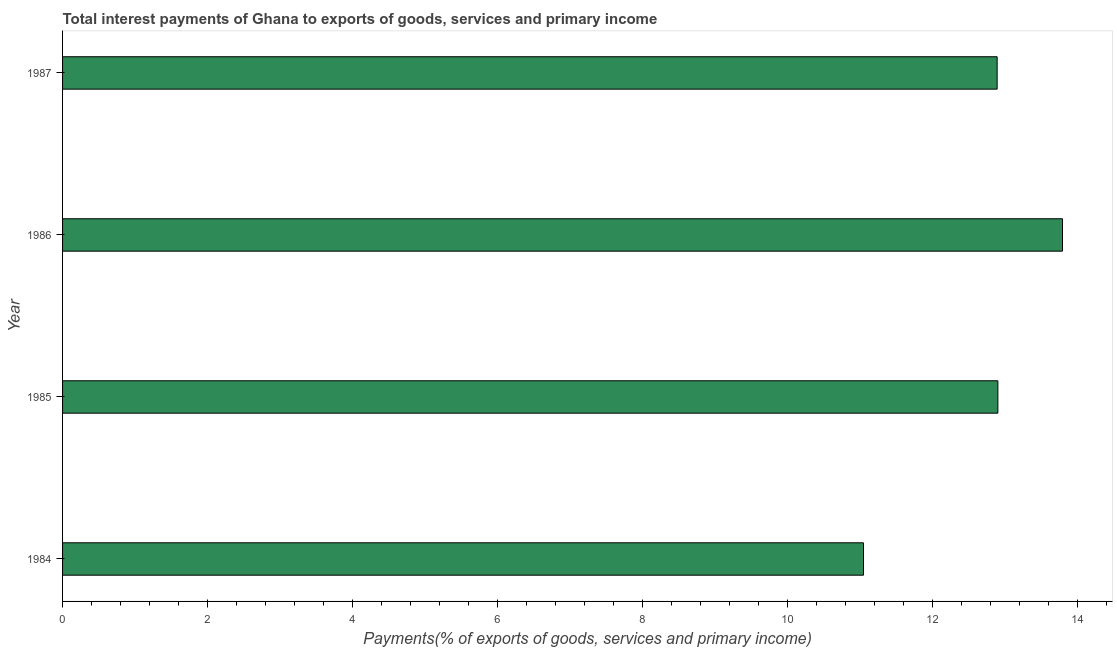Does the graph contain grids?
Provide a short and direct response. No. What is the title of the graph?
Your answer should be compact. Total interest payments of Ghana to exports of goods, services and primary income. What is the label or title of the X-axis?
Offer a terse response. Payments(% of exports of goods, services and primary income). What is the label or title of the Y-axis?
Ensure brevity in your answer.  Year. What is the total interest payments on external debt in 1987?
Ensure brevity in your answer.  12.89. Across all years, what is the maximum total interest payments on external debt?
Your response must be concise. 13.8. Across all years, what is the minimum total interest payments on external debt?
Your answer should be compact. 11.05. In which year was the total interest payments on external debt maximum?
Give a very brief answer. 1986. In which year was the total interest payments on external debt minimum?
Keep it short and to the point. 1984. What is the sum of the total interest payments on external debt?
Offer a very short reply. 50.64. What is the difference between the total interest payments on external debt in 1985 and 1987?
Your answer should be very brief. 0.01. What is the average total interest payments on external debt per year?
Offer a very short reply. 12.66. What is the median total interest payments on external debt?
Give a very brief answer. 12.9. In how many years, is the total interest payments on external debt greater than 6.8 %?
Your response must be concise. 4. What is the ratio of the total interest payments on external debt in 1986 to that in 1987?
Provide a short and direct response. 1.07. Is the difference between the total interest payments on external debt in 1986 and 1987 greater than the difference between any two years?
Your answer should be compact. No. What is the difference between the highest and the second highest total interest payments on external debt?
Keep it short and to the point. 0.89. What is the difference between the highest and the lowest total interest payments on external debt?
Provide a succinct answer. 2.75. How many bars are there?
Ensure brevity in your answer.  4. Are all the bars in the graph horizontal?
Offer a terse response. Yes. What is the Payments(% of exports of goods, services and primary income) in 1984?
Make the answer very short. 11.05. What is the Payments(% of exports of goods, services and primary income) of 1985?
Provide a succinct answer. 12.9. What is the Payments(% of exports of goods, services and primary income) in 1986?
Offer a very short reply. 13.8. What is the Payments(% of exports of goods, services and primary income) in 1987?
Offer a terse response. 12.89. What is the difference between the Payments(% of exports of goods, services and primary income) in 1984 and 1985?
Ensure brevity in your answer.  -1.85. What is the difference between the Payments(% of exports of goods, services and primary income) in 1984 and 1986?
Your answer should be very brief. -2.75. What is the difference between the Payments(% of exports of goods, services and primary income) in 1984 and 1987?
Provide a short and direct response. -1.84. What is the difference between the Payments(% of exports of goods, services and primary income) in 1985 and 1986?
Provide a short and direct response. -0.89. What is the difference between the Payments(% of exports of goods, services and primary income) in 1985 and 1987?
Your answer should be compact. 0.01. What is the difference between the Payments(% of exports of goods, services and primary income) in 1986 and 1987?
Your answer should be compact. 0.9. What is the ratio of the Payments(% of exports of goods, services and primary income) in 1984 to that in 1985?
Offer a very short reply. 0.86. What is the ratio of the Payments(% of exports of goods, services and primary income) in 1984 to that in 1986?
Provide a succinct answer. 0.8. What is the ratio of the Payments(% of exports of goods, services and primary income) in 1984 to that in 1987?
Offer a very short reply. 0.86. What is the ratio of the Payments(% of exports of goods, services and primary income) in 1985 to that in 1986?
Your answer should be very brief. 0.94. What is the ratio of the Payments(% of exports of goods, services and primary income) in 1985 to that in 1987?
Provide a short and direct response. 1. What is the ratio of the Payments(% of exports of goods, services and primary income) in 1986 to that in 1987?
Make the answer very short. 1.07. 